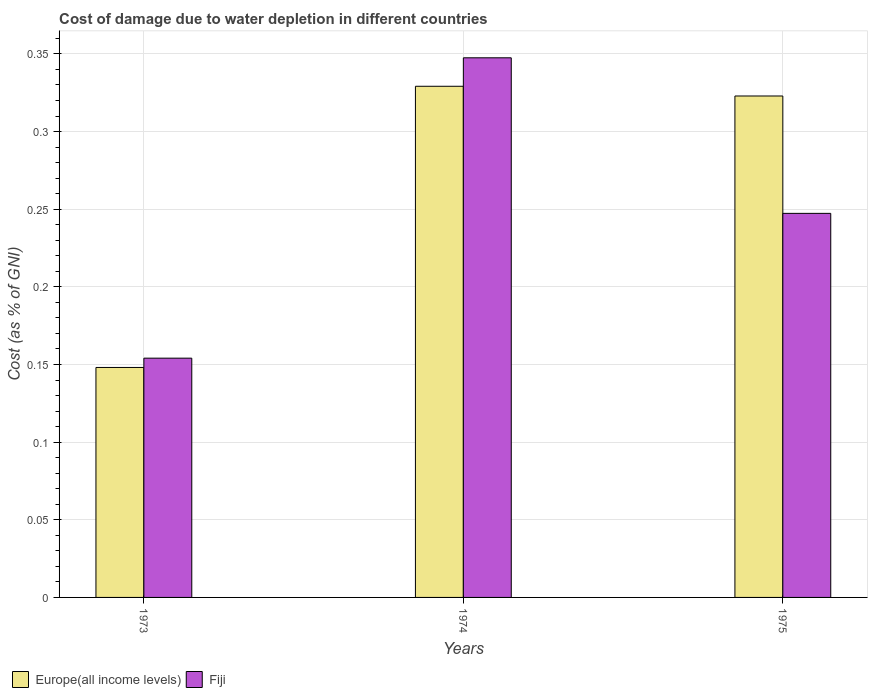How many different coloured bars are there?
Your response must be concise. 2. Are the number of bars per tick equal to the number of legend labels?
Offer a very short reply. Yes. Are the number of bars on each tick of the X-axis equal?
Offer a very short reply. Yes. How many bars are there on the 1st tick from the right?
Your response must be concise. 2. In how many cases, is the number of bars for a given year not equal to the number of legend labels?
Give a very brief answer. 0. What is the cost of damage caused due to water depletion in Europe(all income levels) in 1974?
Ensure brevity in your answer.  0.33. Across all years, what is the maximum cost of damage caused due to water depletion in Europe(all income levels)?
Keep it short and to the point. 0.33. Across all years, what is the minimum cost of damage caused due to water depletion in Fiji?
Provide a short and direct response. 0.15. In which year was the cost of damage caused due to water depletion in Fiji maximum?
Your response must be concise. 1974. In which year was the cost of damage caused due to water depletion in Europe(all income levels) minimum?
Offer a terse response. 1973. What is the total cost of damage caused due to water depletion in Europe(all income levels) in the graph?
Ensure brevity in your answer.  0.8. What is the difference between the cost of damage caused due to water depletion in Fiji in 1973 and that in 1974?
Make the answer very short. -0.19. What is the difference between the cost of damage caused due to water depletion in Fiji in 1975 and the cost of damage caused due to water depletion in Europe(all income levels) in 1973?
Your answer should be very brief. 0.1. What is the average cost of damage caused due to water depletion in Europe(all income levels) per year?
Ensure brevity in your answer.  0.27. In the year 1974, what is the difference between the cost of damage caused due to water depletion in Fiji and cost of damage caused due to water depletion in Europe(all income levels)?
Ensure brevity in your answer.  0.02. What is the ratio of the cost of damage caused due to water depletion in Europe(all income levels) in 1974 to that in 1975?
Keep it short and to the point. 1.02. Is the cost of damage caused due to water depletion in Europe(all income levels) in 1973 less than that in 1975?
Your answer should be very brief. Yes. What is the difference between the highest and the second highest cost of damage caused due to water depletion in Fiji?
Keep it short and to the point. 0.1. What is the difference between the highest and the lowest cost of damage caused due to water depletion in Europe(all income levels)?
Offer a terse response. 0.18. Is the sum of the cost of damage caused due to water depletion in Fiji in 1973 and 1975 greater than the maximum cost of damage caused due to water depletion in Europe(all income levels) across all years?
Offer a very short reply. Yes. What does the 1st bar from the left in 1975 represents?
Keep it short and to the point. Europe(all income levels). What does the 2nd bar from the right in 1975 represents?
Provide a succinct answer. Europe(all income levels). How many bars are there?
Ensure brevity in your answer.  6. Does the graph contain any zero values?
Offer a very short reply. No. Does the graph contain grids?
Provide a short and direct response. Yes. Where does the legend appear in the graph?
Provide a succinct answer. Bottom left. What is the title of the graph?
Ensure brevity in your answer.  Cost of damage due to water depletion in different countries. Does "Cambodia" appear as one of the legend labels in the graph?
Provide a succinct answer. No. What is the label or title of the X-axis?
Provide a succinct answer. Years. What is the label or title of the Y-axis?
Your answer should be very brief. Cost (as % of GNI). What is the Cost (as % of GNI) in Europe(all income levels) in 1973?
Offer a terse response. 0.15. What is the Cost (as % of GNI) in Fiji in 1973?
Provide a short and direct response. 0.15. What is the Cost (as % of GNI) in Europe(all income levels) in 1974?
Give a very brief answer. 0.33. What is the Cost (as % of GNI) in Fiji in 1974?
Keep it short and to the point. 0.35. What is the Cost (as % of GNI) in Europe(all income levels) in 1975?
Ensure brevity in your answer.  0.32. What is the Cost (as % of GNI) of Fiji in 1975?
Your answer should be compact. 0.25. Across all years, what is the maximum Cost (as % of GNI) of Europe(all income levels)?
Keep it short and to the point. 0.33. Across all years, what is the maximum Cost (as % of GNI) in Fiji?
Give a very brief answer. 0.35. Across all years, what is the minimum Cost (as % of GNI) in Europe(all income levels)?
Give a very brief answer. 0.15. Across all years, what is the minimum Cost (as % of GNI) of Fiji?
Provide a short and direct response. 0.15. What is the total Cost (as % of GNI) in Europe(all income levels) in the graph?
Provide a succinct answer. 0.8. What is the total Cost (as % of GNI) in Fiji in the graph?
Your answer should be compact. 0.75. What is the difference between the Cost (as % of GNI) of Europe(all income levels) in 1973 and that in 1974?
Offer a terse response. -0.18. What is the difference between the Cost (as % of GNI) in Fiji in 1973 and that in 1974?
Offer a terse response. -0.19. What is the difference between the Cost (as % of GNI) in Europe(all income levels) in 1973 and that in 1975?
Provide a short and direct response. -0.17. What is the difference between the Cost (as % of GNI) in Fiji in 1973 and that in 1975?
Ensure brevity in your answer.  -0.09. What is the difference between the Cost (as % of GNI) in Europe(all income levels) in 1974 and that in 1975?
Keep it short and to the point. 0.01. What is the difference between the Cost (as % of GNI) of Fiji in 1974 and that in 1975?
Your response must be concise. 0.1. What is the difference between the Cost (as % of GNI) of Europe(all income levels) in 1973 and the Cost (as % of GNI) of Fiji in 1974?
Keep it short and to the point. -0.2. What is the difference between the Cost (as % of GNI) in Europe(all income levels) in 1973 and the Cost (as % of GNI) in Fiji in 1975?
Ensure brevity in your answer.  -0.1. What is the difference between the Cost (as % of GNI) of Europe(all income levels) in 1974 and the Cost (as % of GNI) of Fiji in 1975?
Offer a very short reply. 0.08. What is the average Cost (as % of GNI) in Europe(all income levels) per year?
Your answer should be compact. 0.27. What is the average Cost (as % of GNI) of Fiji per year?
Offer a terse response. 0.25. In the year 1973, what is the difference between the Cost (as % of GNI) in Europe(all income levels) and Cost (as % of GNI) in Fiji?
Your answer should be compact. -0.01. In the year 1974, what is the difference between the Cost (as % of GNI) of Europe(all income levels) and Cost (as % of GNI) of Fiji?
Give a very brief answer. -0.02. In the year 1975, what is the difference between the Cost (as % of GNI) in Europe(all income levels) and Cost (as % of GNI) in Fiji?
Provide a succinct answer. 0.08. What is the ratio of the Cost (as % of GNI) of Europe(all income levels) in 1973 to that in 1974?
Your response must be concise. 0.45. What is the ratio of the Cost (as % of GNI) in Fiji in 1973 to that in 1974?
Make the answer very short. 0.44. What is the ratio of the Cost (as % of GNI) of Europe(all income levels) in 1973 to that in 1975?
Ensure brevity in your answer.  0.46. What is the ratio of the Cost (as % of GNI) in Fiji in 1973 to that in 1975?
Provide a short and direct response. 0.62. What is the ratio of the Cost (as % of GNI) in Europe(all income levels) in 1974 to that in 1975?
Your answer should be very brief. 1.02. What is the ratio of the Cost (as % of GNI) in Fiji in 1974 to that in 1975?
Offer a terse response. 1.41. What is the difference between the highest and the second highest Cost (as % of GNI) of Europe(all income levels)?
Provide a short and direct response. 0.01. What is the difference between the highest and the second highest Cost (as % of GNI) of Fiji?
Your answer should be compact. 0.1. What is the difference between the highest and the lowest Cost (as % of GNI) in Europe(all income levels)?
Offer a terse response. 0.18. What is the difference between the highest and the lowest Cost (as % of GNI) in Fiji?
Provide a short and direct response. 0.19. 